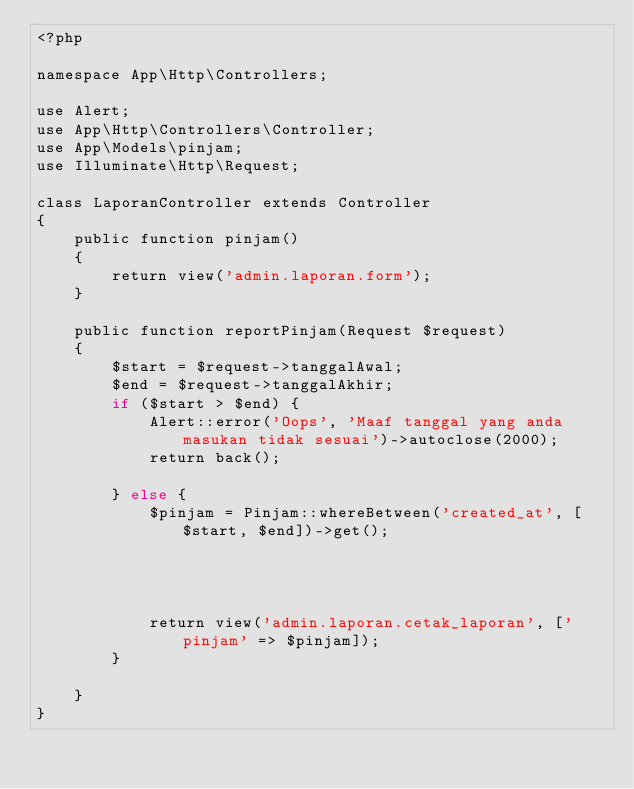Convert code to text. <code><loc_0><loc_0><loc_500><loc_500><_PHP_><?php

namespace App\Http\Controllers;

use Alert;
use App\Http\Controllers\Controller;
use App\Models\pinjam;
use Illuminate\Http\Request;

class LaporanController extends Controller
{
    public function pinjam()
    {
        return view('admin.laporan.form');
    }

    public function reportPinjam(Request $request)
    {
        $start = $request->tanggalAwal;
        $end = $request->tanggalAkhir;
        if ($start > $end) {
            Alert::error('Oops', 'Maaf tanggal yang anda masukan tidak sesuai')->autoclose(2000);
            return back();

        } else {
            $pinjam = Pinjam::whereBetween('created_at', [$start, $end])->get();

            
            
         
            return view('admin.laporan.cetak_laporan', ['pinjam' => $pinjam]);
        }

    }
}</code> 